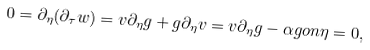Convert formula to latex. <formula><loc_0><loc_0><loc_500><loc_500>0 = \partial _ { \eta } ( \partial _ { \tau } w ) = v \partial _ { \eta } g + g \partial _ { \eta } v = v \partial _ { \eta } g - \alpha g o n \eta = 0 ,</formula> 